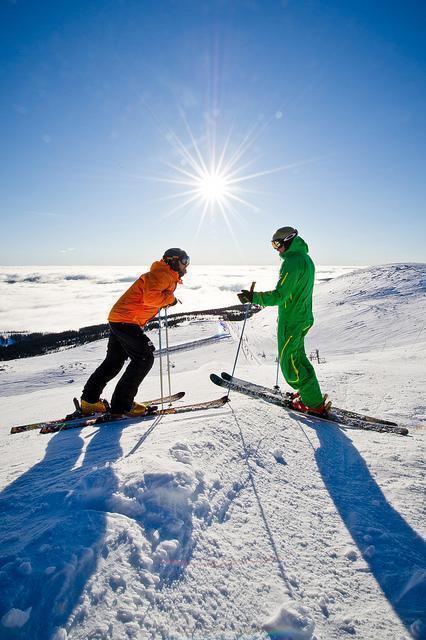What part of the world are the skiers most likely in?
Indicate the correct response by choosing from the four available options to answer the question.
Options: South america, antarctica, colorado, india. Colorado. 